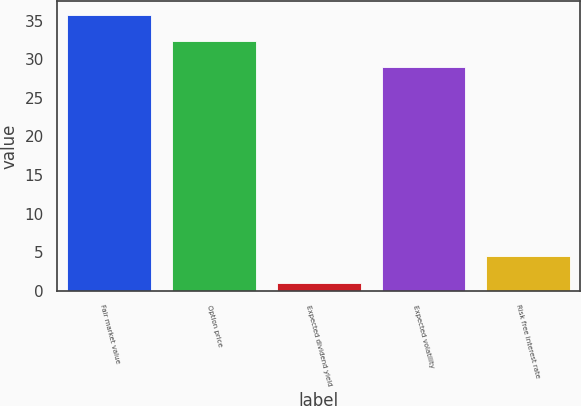Convert chart to OTSL. <chart><loc_0><loc_0><loc_500><loc_500><bar_chart><fcel>Fair market value<fcel>Option price<fcel>Expected dividend yield<fcel>Expected volatility<fcel>Risk free interest rate<nl><fcel>35.72<fcel>32.36<fcel>1.07<fcel>29<fcel>4.57<nl></chart> 